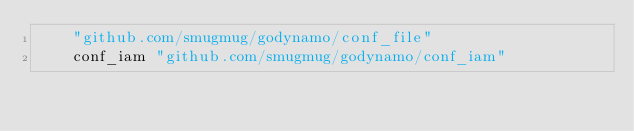<code> <loc_0><loc_0><loc_500><loc_500><_Go_>	"github.com/smugmug/godynamo/conf_file"
	conf_iam "github.com/smugmug/godynamo/conf_iam"</code> 